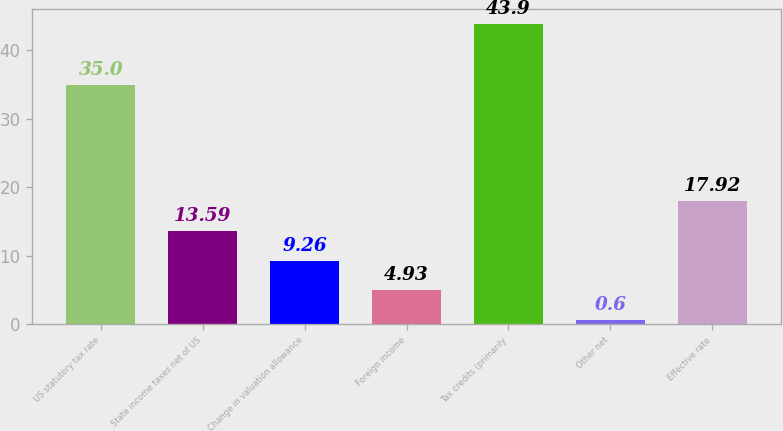Convert chart to OTSL. <chart><loc_0><loc_0><loc_500><loc_500><bar_chart><fcel>US statutory tax rate<fcel>State income taxes net of US<fcel>Change in valuation allowance<fcel>Foreign income<fcel>Tax credits (primarily<fcel>Other net<fcel>Effective rate<nl><fcel>35<fcel>13.59<fcel>9.26<fcel>4.93<fcel>43.9<fcel>0.6<fcel>17.92<nl></chart> 